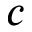<formula> <loc_0><loc_0><loc_500><loc_500>c</formula> 